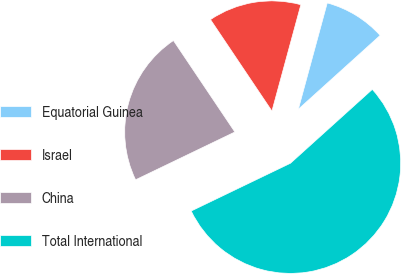Convert chart to OTSL. <chart><loc_0><loc_0><loc_500><loc_500><pie_chart><fcel>Equatorial Guinea<fcel>Israel<fcel>China<fcel>Total International<nl><fcel>9.09%<fcel>13.64%<fcel>22.73%<fcel>54.55%<nl></chart> 